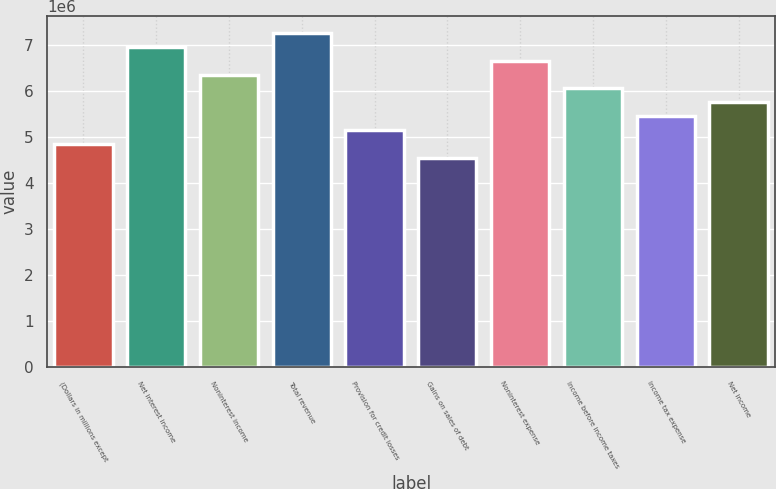Convert chart to OTSL. <chart><loc_0><loc_0><loc_500><loc_500><bar_chart><fcel>(Dollars in millions except<fcel>Net interest income<fcel>Noninterest income<fcel>Total revenue<fcel>Provision for credit losses<fcel>Gains on sales of debt<fcel>Noninterest expense<fcel>Income before income taxes<fcel>Income tax expense<fcel>Net income<nl><fcel>4.84857e+06<fcel>6.96982e+06<fcel>6.36375e+06<fcel>7.27285e+06<fcel>5.1516e+06<fcel>4.54553e+06<fcel>6.66678e+06<fcel>6.06071e+06<fcel>5.45464e+06<fcel>5.75768e+06<nl></chart> 